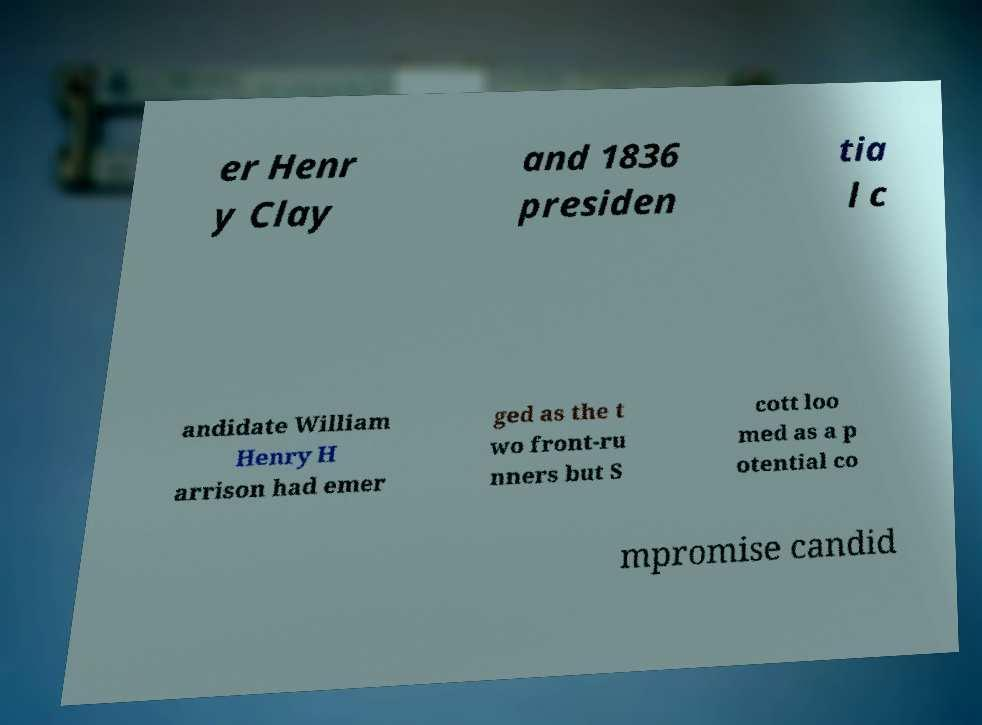I need the written content from this picture converted into text. Can you do that? er Henr y Clay and 1836 presiden tia l c andidate William Henry H arrison had emer ged as the t wo front-ru nners but S cott loo med as a p otential co mpromise candid 